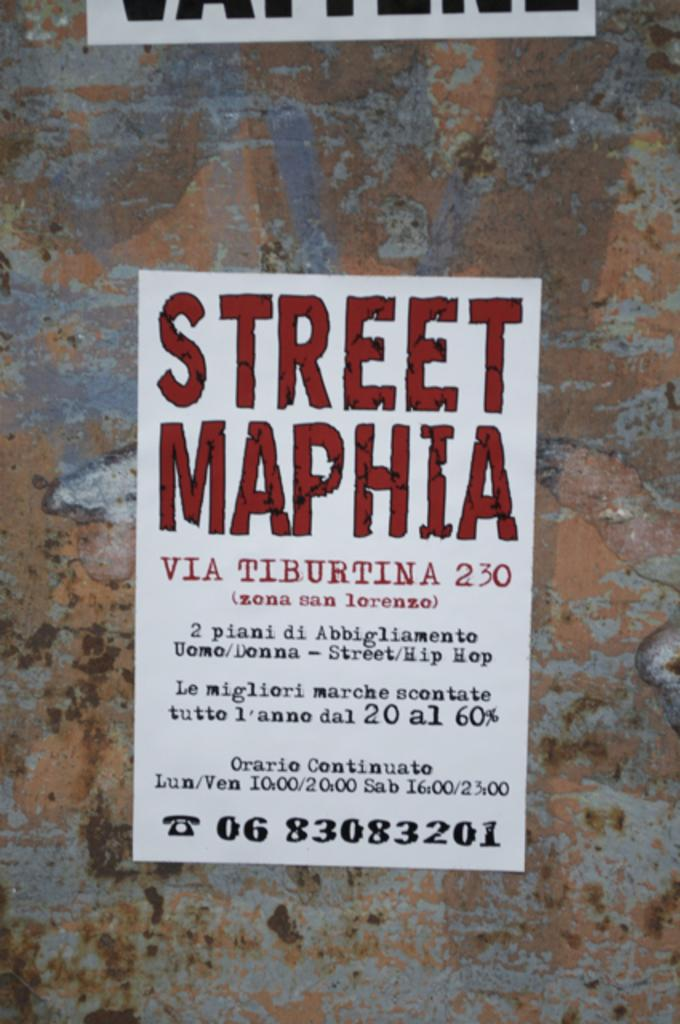<image>
Share a concise interpretation of the image provided. A poster for "Street Maphia" is hanging on a stone wall. 